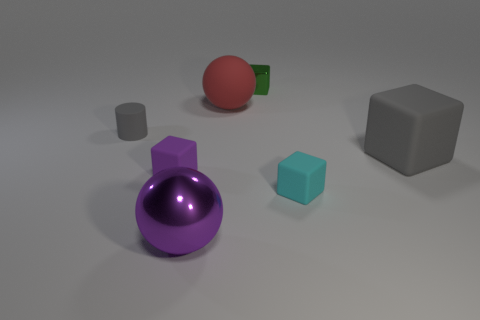There is a object that is the same color as the large rubber cube; what shape is it?
Your answer should be very brief. Cylinder. What is the size of the object that is the same color as the tiny cylinder?
Ensure brevity in your answer.  Large. How many other things are there of the same size as the cyan rubber block?
Make the answer very short. 3. How many small things are there?
Make the answer very short. 4. Do the matte ball and the purple metal sphere have the same size?
Provide a succinct answer. Yes. What number of other things are there of the same shape as the cyan object?
Your answer should be compact. 3. There is a big purple object that is in front of the shiny object that is to the right of the big metallic thing; what is it made of?
Ensure brevity in your answer.  Metal. There is a gray rubber block; are there any big purple metal objects in front of it?
Your answer should be compact. Yes. Does the green thing have the same size as the rubber block left of the big red matte thing?
Your answer should be very brief. Yes. What size is the cyan object that is the same shape as the small green object?
Provide a short and direct response. Small. 